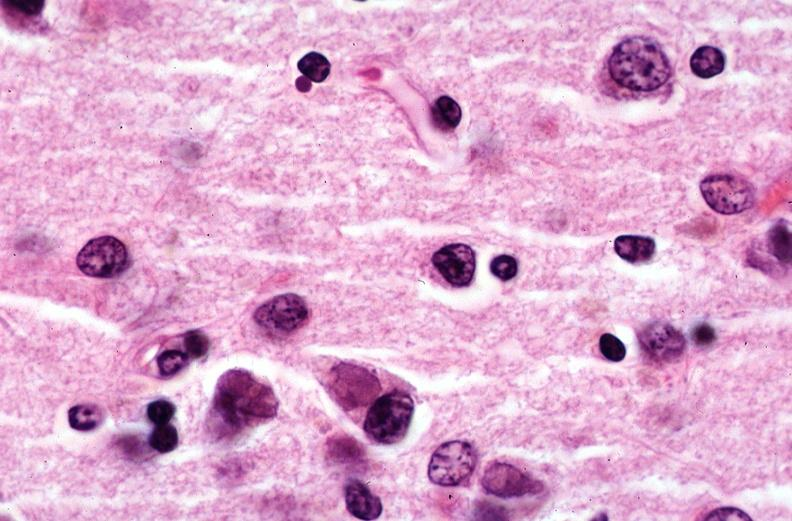what is present?
Answer the question using a single word or phrase. Nervous 